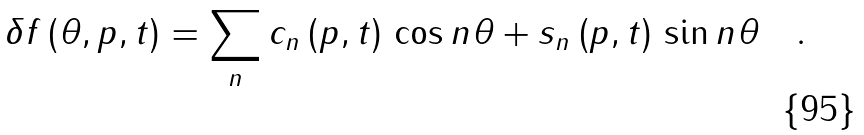<formula> <loc_0><loc_0><loc_500><loc_500>\delta f \left ( \theta , p , t \right ) = \sum _ { n } c _ { n } \left ( p , t \right ) \, \cos n \theta + s _ { n } \left ( p , t \right ) \, \sin n \theta \quad .</formula> 